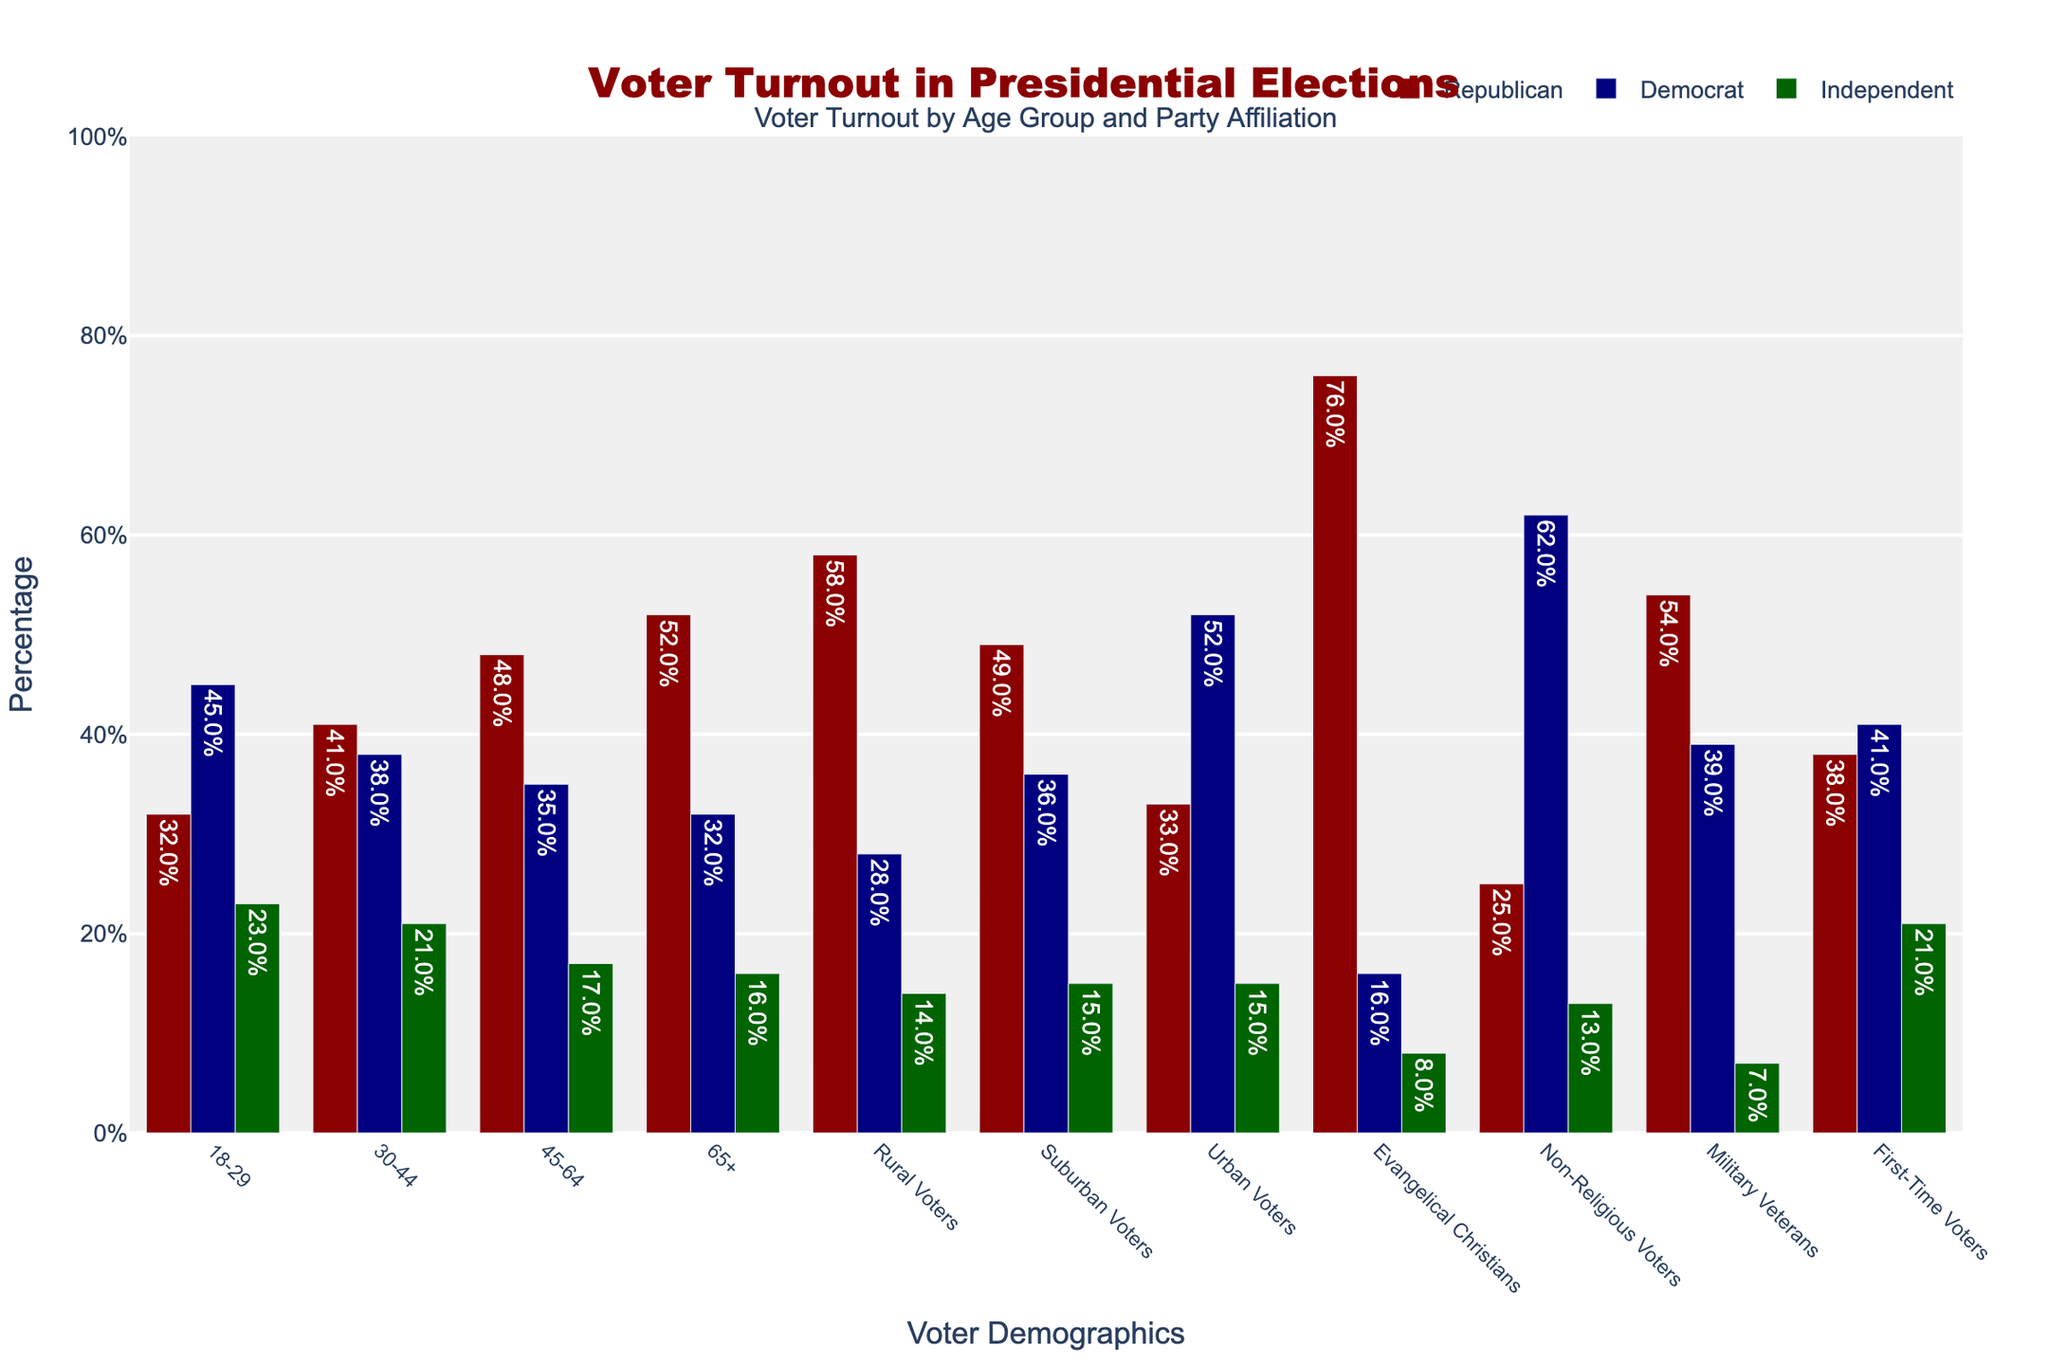Which age group has the highest percentage of Republican voters? To find the answer, look for the group with the tallest red bar. The tallest red bar is in the 65+ age group at 52%.
Answer: 65+ Which voter demographic has the lowest percentage of Independent voters? To find this, look for the shortest green bar. The shortest green bar represents Evangelical Christians at 8%.
Answer: Evangelical Christians What is the difference in percentage between Republican and Democrat voters among rural voters? Find the height of the red and navy bars for rural voters. The red bar (Republicans) is 58%, and the navy bar (Democrats) is 28%. The difference is 58% - 28% = 30%.
Answer: 30% Which age group has the smallest difference in voter turnout between Republicans and Democrats? Look at all age groups and calculate the difference between red and navy bars for each. The 30-44 age group has the smallest difference (41% Republican - 38% Democrat = 3%).
Answer: 30-44 Which group has a higher percentage of Democrat voters: urban voters or first-time voters? Look for the heights of the navy bars for these groups. Urban voters have 52%, and first-time voters have 41%. Urban voters have a higher percentage.
Answer: Urban voters What is the average percentage of Republican voters across all age groups? Add up the Republican percentages for all age groups (32% + 41% + 48% + 52%) and divide by the number of age groups (4). The average is (32% + 41% + 48% + 52%) / 4 = 43.25%.
Answer: 43.25% What is the combined percentage of Democrat and Independent voters among non-religious voters? Find the heights of the navy and green bars for non-religious voters. Navy (Democrats) is 62%, and green (Independents) is 13%. The combined percentage is 62% + 13% = 75%.
Answer: 75% Which voter demographic shows the highest support for the Republican Party? Look for the tallest red bar. The tallest red bar represents Evangelical Christians at 76%.
Answer: Evangelical Christians What is the percentage difference between military veterans who vote Republican and the general Republican turnout in the 45-64 age group? The red bar for military veterans is 54%, and for the 45-64 age group, it is 48%. The difference is 54% - 48% = 6%.
Answer: 6% Which group has the highest percentage of Democrat voters? Look for the tallest navy bar. The tallest navy bar represents urban voters at 52%.
Answer: Urban voters 